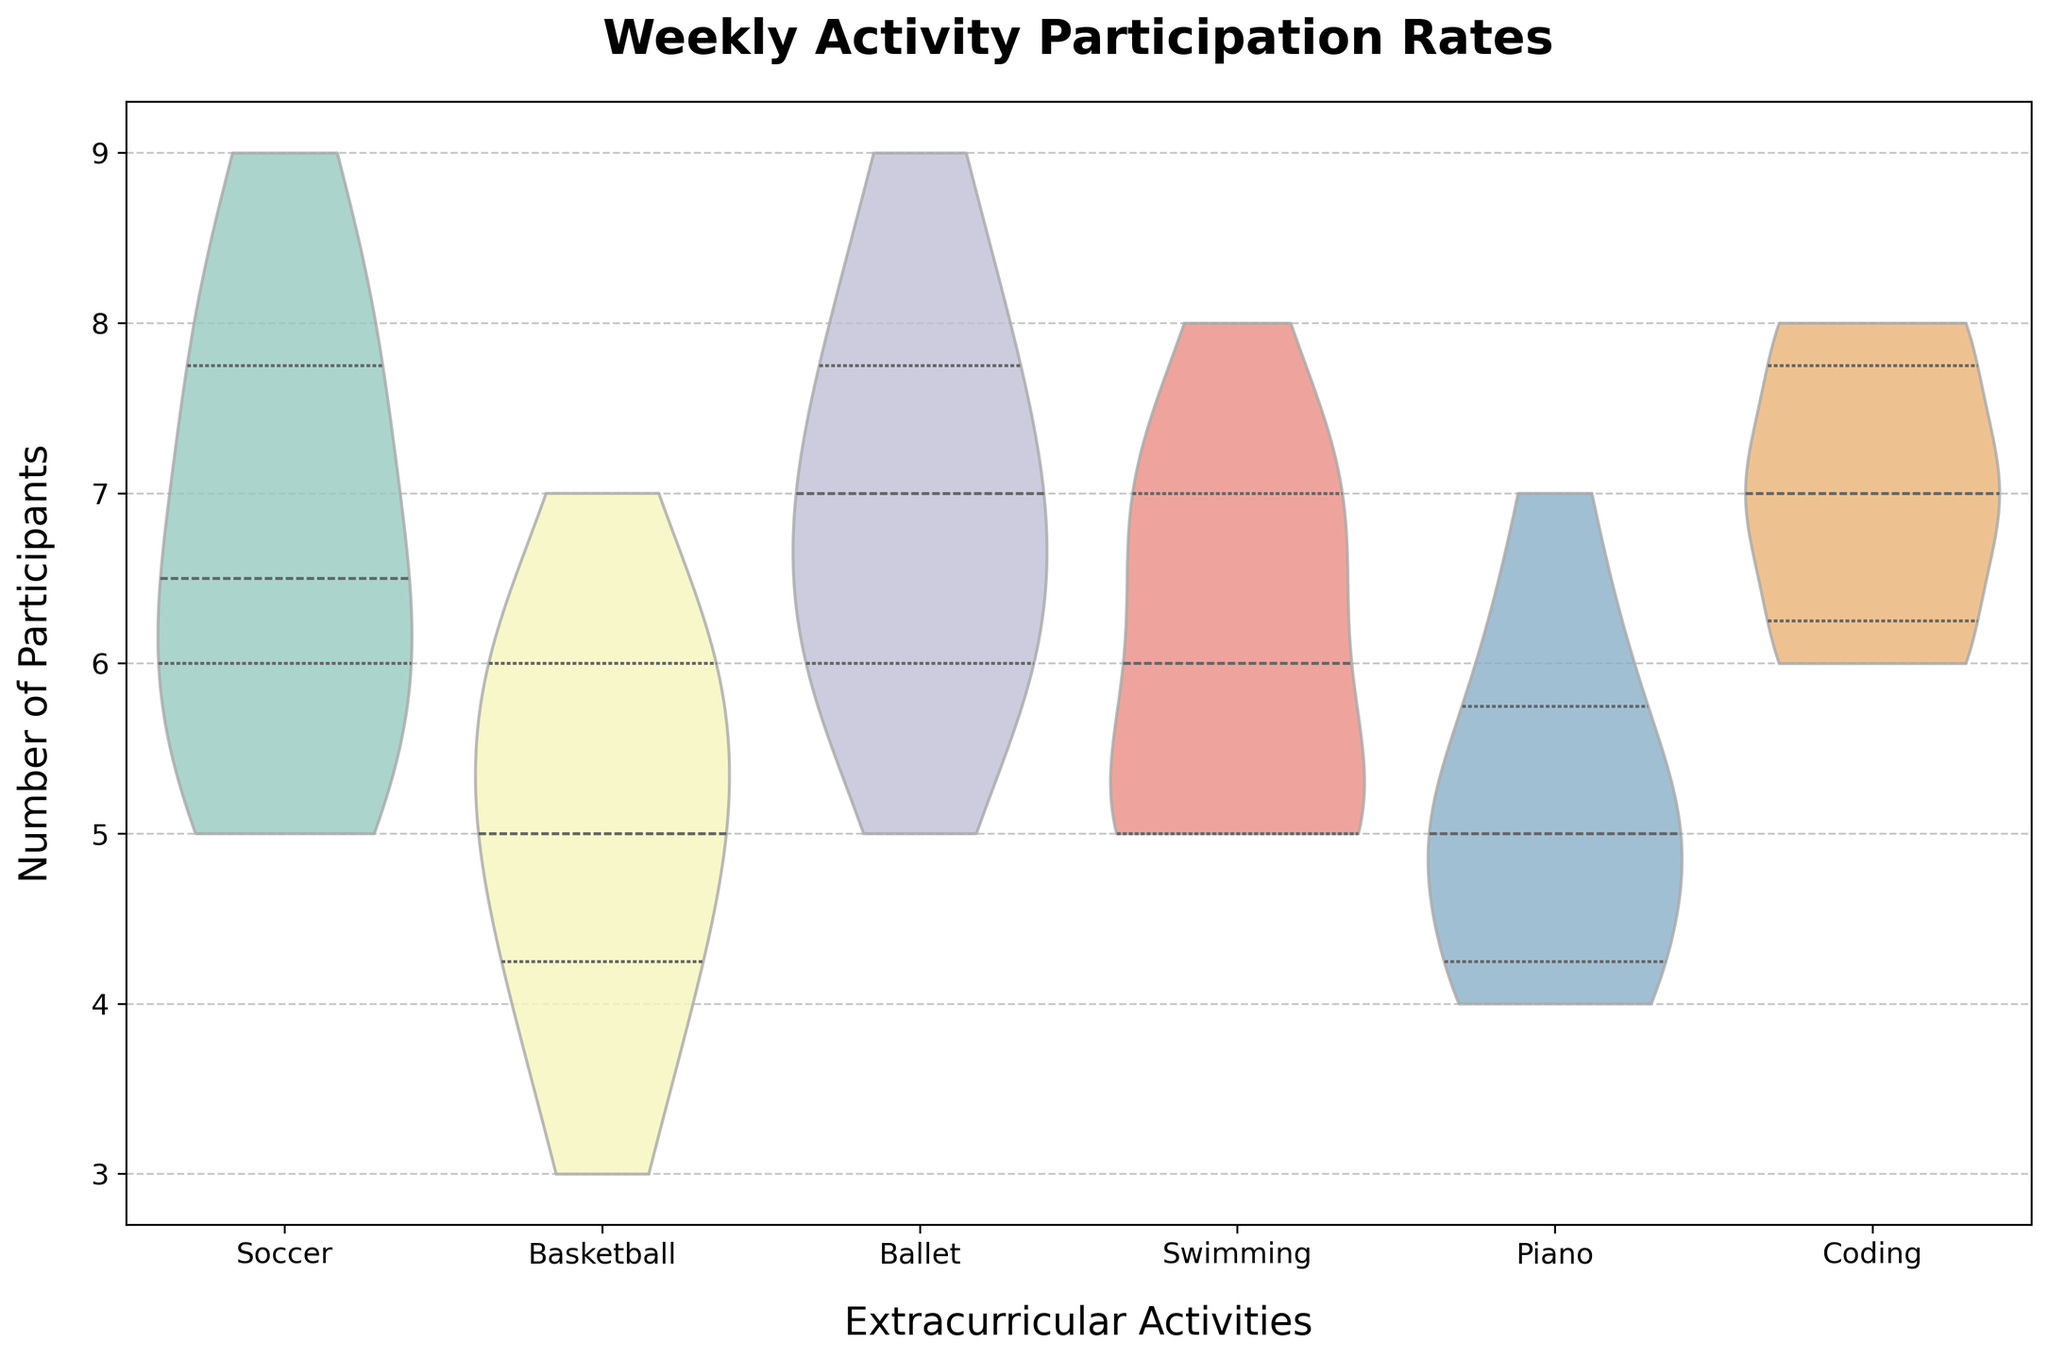How many activities are represented in the figure? The x-axis lists all the activities shown in the figure. Count the distinct categories.
Answer: 6 What's the range of the number of participants for Soccer? The top and bottom edges of the violin plot for Soccer reflect the range of participants. Identify these extremities.
Answer: 5-9 Which activity has the highest median number of participants? Locate the horizontal line inside each violin plot representing the median. Compare the median lines across all activities.
Answer: Coding How does the median participation for Swimming compare to that for Piano? Identify the median lines for both Swimming and Piano in their respective violin plots and compare their heights.
Answer: Swimming is higher What is the interquartile range (IQR) for Basketball? Inspect the inner box within the Basketball violin plot. The box edges represent the first and third quartiles. Subtract the value at the bottom edge from the top edge to find the IQR.
Answer: 2 (from 4 to 6) Are there any activities that show similar distributions? Look for activities with similarly shaped and spread-out violin plots, indicating similar distributions.
Answer: Soccer and Swimming Which activity has the most inconsistent participation rates? Identify the activity with the widest and most spread-out violin plot, which indicates variability.
Answer: Piano What percentage of time is Soccer's participation median higher than 6? Check the position of the median line in the Soccer violin plot. If it is higher than 6, divide 60 by 100 (from the five to seven index range) to express as a percentage.
Answer: 100% 